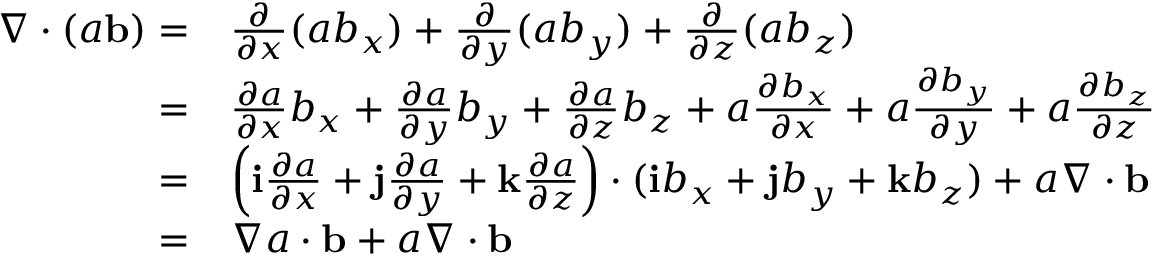Convert formula to latex. <formula><loc_0><loc_0><loc_500><loc_500>\begin{array} { r l } { \nabla \cdot ( a { \mathbf b } ) = } & { \frac { \partial } { \partial x } ( a b _ { x } ) + \frac { \partial } { \partial y } ( a b _ { y } ) + \frac { \partial } { \partial z } ( a b _ { z } ) } \\ { = } & { \frac { \partial a } { \partial x } b _ { x } + \frac { \partial a } { \partial y } b _ { y } + \frac { \partial a } { \partial z } b _ { z } + a \frac { \partial b _ { x } } { \partial x } + a \frac { \partial b _ { y } } { \partial y } + a \frac { \partial b _ { z } } { \partial z } } \\ { = } & { \left ( i \frac { \partial a } { \partial x } + j \frac { \partial a } { \partial y } + k \frac { \partial a } { \partial z } \right ) \cdot ( i b _ { x } + j b _ { y } + k b _ { z } ) + a \nabla \cdot { \mathbf b } } \\ { = } & { \nabla a \cdot { \mathbf b } + a \nabla \cdot { \mathbf b } } \end{array}</formula> 